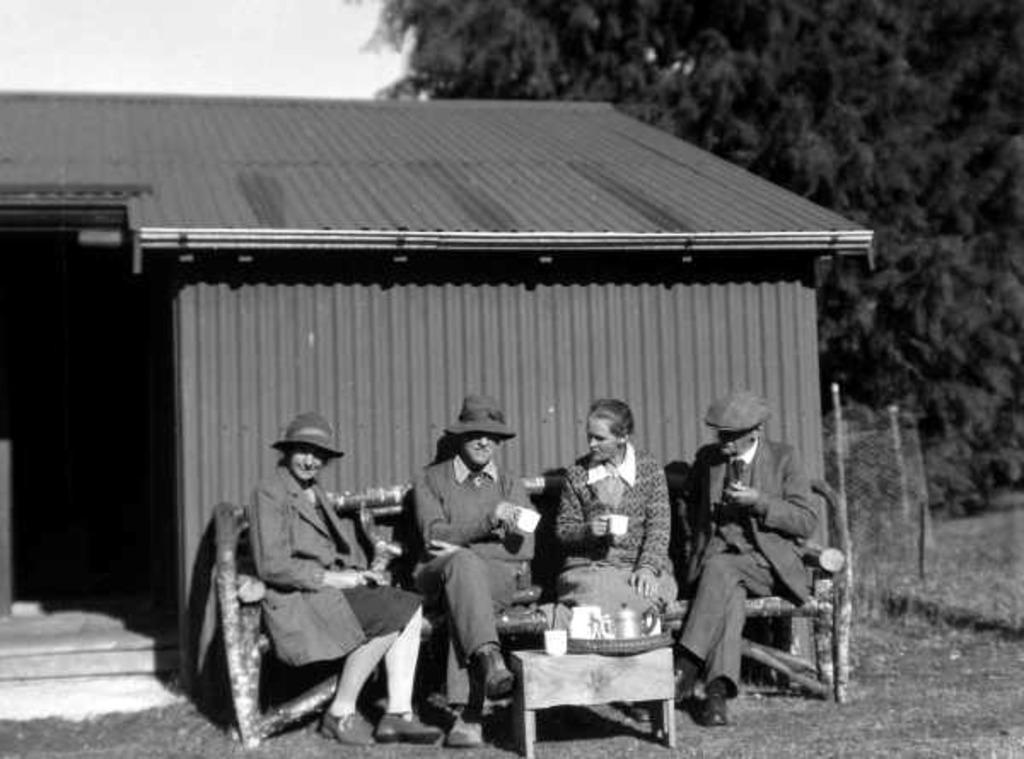Can you describe this image briefly? In this image we can see some people sitting on the bench holding cups. We can also see a tie pie with a tea jar, cup and a basket in front of them. On the backside we can see a house with roof, trees, fence and the sky. 